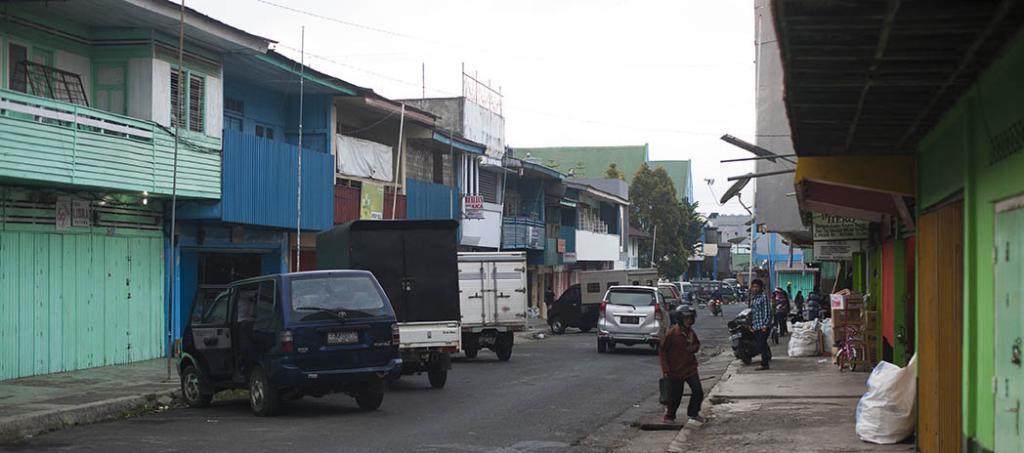Describe this image in one or two sentences. The picture is clicked outside a street. In the center of the picture there are vehicles, people and other objects. In the picture there are houses, trees and other objects. Sky is cloudy. 